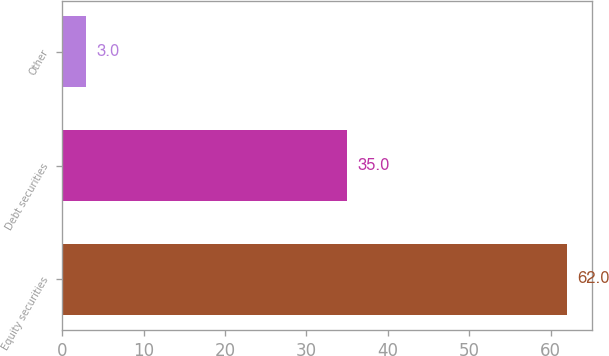Convert chart. <chart><loc_0><loc_0><loc_500><loc_500><bar_chart><fcel>Equity securities<fcel>Debt securities<fcel>Other<nl><fcel>62<fcel>35<fcel>3<nl></chart> 